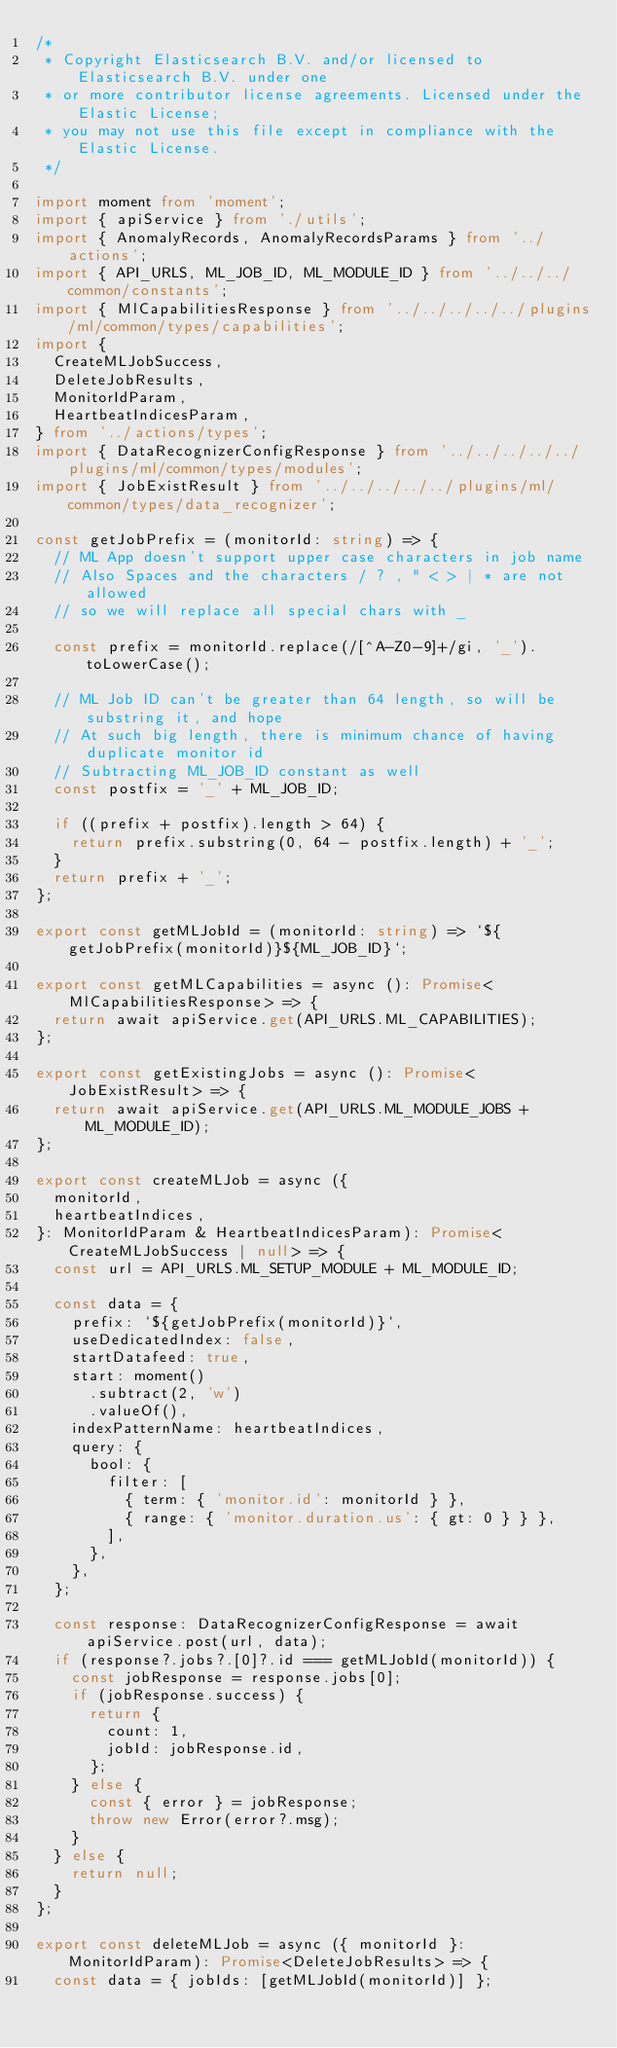<code> <loc_0><loc_0><loc_500><loc_500><_TypeScript_>/*
 * Copyright Elasticsearch B.V. and/or licensed to Elasticsearch B.V. under one
 * or more contributor license agreements. Licensed under the Elastic License;
 * you may not use this file except in compliance with the Elastic License.
 */

import moment from 'moment';
import { apiService } from './utils';
import { AnomalyRecords, AnomalyRecordsParams } from '../actions';
import { API_URLS, ML_JOB_ID, ML_MODULE_ID } from '../../../common/constants';
import { MlCapabilitiesResponse } from '../../../../../plugins/ml/common/types/capabilities';
import {
  CreateMLJobSuccess,
  DeleteJobResults,
  MonitorIdParam,
  HeartbeatIndicesParam,
} from '../actions/types';
import { DataRecognizerConfigResponse } from '../../../../../plugins/ml/common/types/modules';
import { JobExistResult } from '../../../../../plugins/ml/common/types/data_recognizer';

const getJobPrefix = (monitorId: string) => {
  // ML App doesn't support upper case characters in job name
  // Also Spaces and the characters / ? , " < > | * are not allowed
  // so we will replace all special chars with _

  const prefix = monitorId.replace(/[^A-Z0-9]+/gi, '_').toLowerCase();

  // ML Job ID can't be greater than 64 length, so will be substring it, and hope
  // At such big length, there is minimum chance of having duplicate monitor id
  // Subtracting ML_JOB_ID constant as well
  const postfix = '_' + ML_JOB_ID;

  if ((prefix + postfix).length > 64) {
    return prefix.substring(0, 64 - postfix.length) + '_';
  }
  return prefix + '_';
};

export const getMLJobId = (monitorId: string) => `${getJobPrefix(monitorId)}${ML_JOB_ID}`;

export const getMLCapabilities = async (): Promise<MlCapabilitiesResponse> => {
  return await apiService.get(API_URLS.ML_CAPABILITIES);
};

export const getExistingJobs = async (): Promise<JobExistResult> => {
  return await apiService.get(API_URLS.ML_MODULE_JOBS + ML_MODULE_ID);
};

export const createMLJob = async ({
  monitorId,
  heartbeatIndices,
}: MonitorIdParam & HeartbeatIndicesParam): Promise<CreateMLJobSuccess | null> => {
  const url = API_URLS.ML_SETUP_MODULE + ML_MODULE_ID;

  const data = {
    prefix: `${getJobPrefix(monitorId)}`,
    useDedicatedIndex: false,
    startDatafeed: true,
    start: moment()
      .subtract(2, 'w')
      .valueOf(),
    indexPatternName: heartbeatIndices,
    query: {
      bool: {
        filter: [
          { term: { 'monitor.id': monitorId } },
          { range: { 'monitor.duration.us': { gt: 0 } } },
        ],
      },
    },
  };

  const response: DataRecognizerConfigResponse = await apiService.post(url, data);
  if (response?.jobs?.[0]?.id === getMLJobId(monitorId)) {
    const jobResponse = response.jobs[0];
    if (jobResponse.success) {
      return {
        count: 1,
        jobId: jobResponse.id,
      };
    } else {
      const { error } = jobResponse;
      throw new Error(error?.msg);
    }
  } else {
    return null;
  }
};

export const deleteMLJob = async ({ monitorId }: MonitorIdParam): Promise<DeleteJobResults> => {
  const data = { jobIds: [getMLJobId(monitorId)] };
</code> 